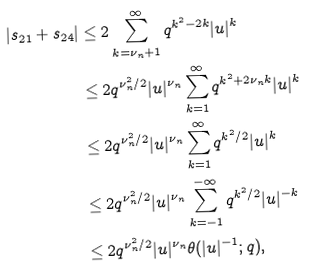<formula> <loc_0><loc_0><loc_500><loc_500>| s _ { 2 1 } + s _ { 2 4 } | & \leq 2 \sum _ { k = \nu _ { n } + 1 } ^ { \infty } q ^ { k ^ { 2 } - 2 k } | u | ^ { k } \\ & \leq 2 q ^ { \nu _ { n } ^ { 2 } / 2 } | u | ^ { \nu _ { n } } \sum _ { k = 1 } ^ { \infty } q ^ { k ^ { 2 } + 2 \nu _ { n } k } | u | ^ { k } \\ & \leq 2 q ^ { \nu _ { n } ^ { 2 } / 2 } | u | ^ { \nu _ { n } } \sum _ { k = 1 } ^ { \infty } q ^ { k ^ { 2 } / 2 } | u | ^ { k } \\ & \leq 2 q ^ { \nu _ { n } ^ { 2 } / 2 } | u | ^ { \nu _ { n } } \sum _ { k = - 1 } ^ { - \infty } q ^ { k ^ { 2 } / 2 } | u | ^ { - k } \\ & \leq 2 q ^ { \nu _ { n } ^ { 2 } / 2 } | u | ^ { \nu _ { n } } \theta ( | u | ^ { - 1 } ; q ) ,</formula> 